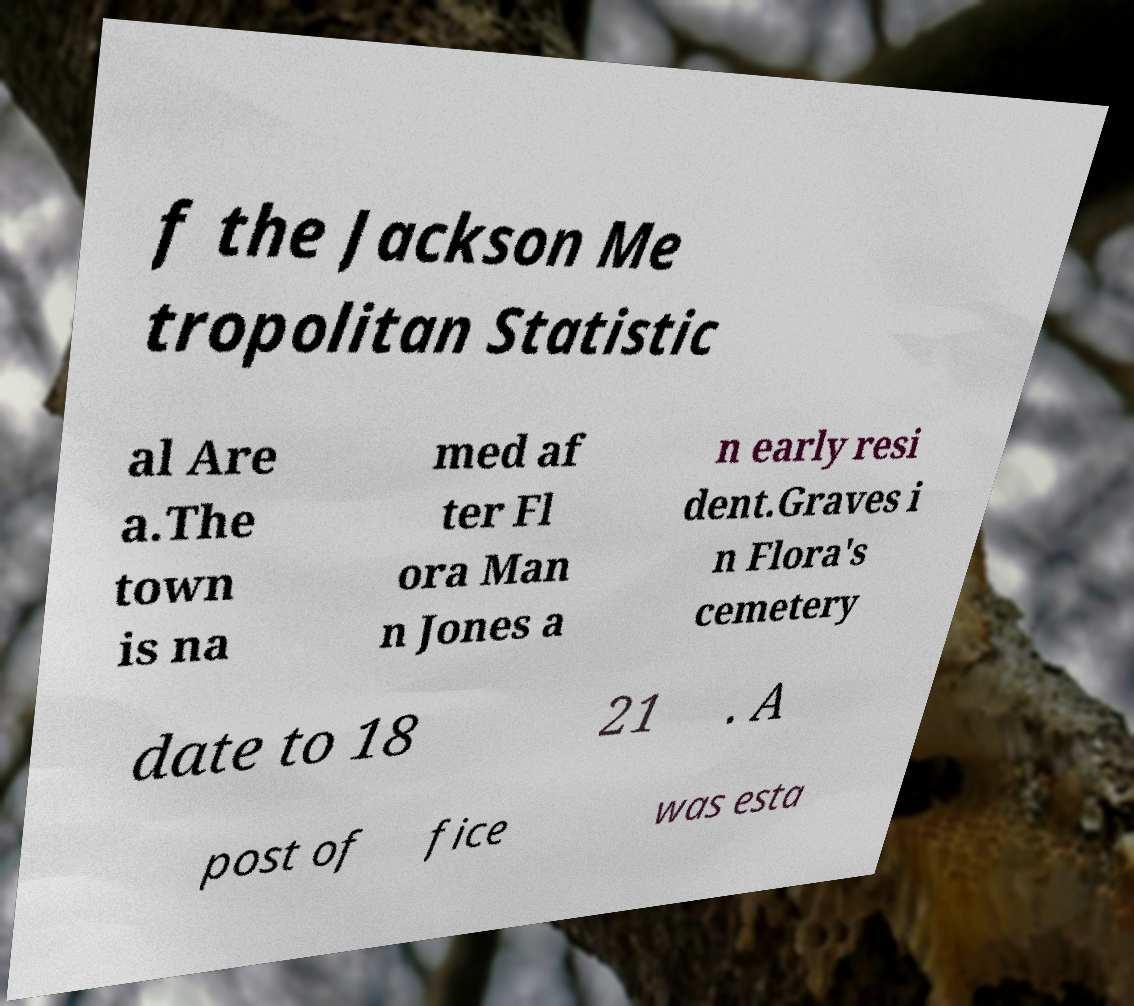Can you read and provide the text displayed in the image?This photo seems to have some interesting text. Can you extract and type it out for me? f the Jackson Me tropolitan Statistic al Are a.The town is na med af ter Fl ora Man n Jones a n early resi dent.Graves i n Flora's cemetery date to 18 21 . A post of fice was esta 